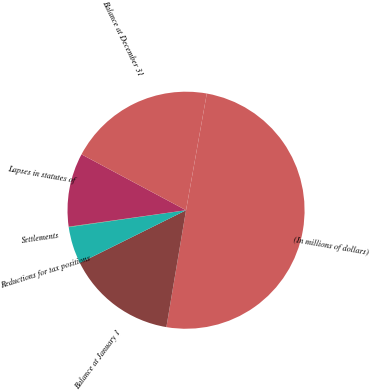Convert chart to OTSL. <chart><loc_0><loc_0><loc_500><loc_500><pie_chart><fcel>(In millions of dollars)<fcel>Balance at January 1<fcel>Reductions for tax positions<fcel>Settlements<fcel>Lapses in statutes of<fcel>Balance at December 31<nl><fcel>49.85%<fcel>15.01%<fcel>5.05%<fcel>0.07%<fcel>10.03%<fcel>19.99%<nl></chart> 